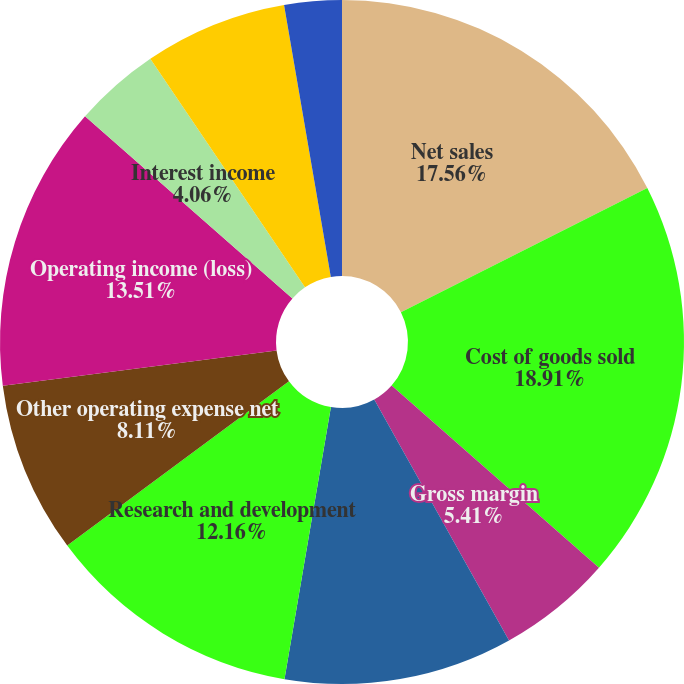<chart> <loc_0><loc_0><loc_500><loc_500><pie_chart><fcel>Net sales<fcel>Cost of goods sold<fcel>Gross margin<fcel>Selling general and<fcel>Research and development<fcel>Other operating expense net<fcel>Operating income (loss)<fcel>Interest income<fcel>Interest expense<fcel>Other non-operating income<nl><fcel>17.56%<fcel>18.91%<fcel>5.41%<fcel>10.81%<fcel>12.16%<fcel>8.11%<fcel>13.51%<fcel>4.06%<fcel>6.76%<fcel>2.71%<nl></chart> 